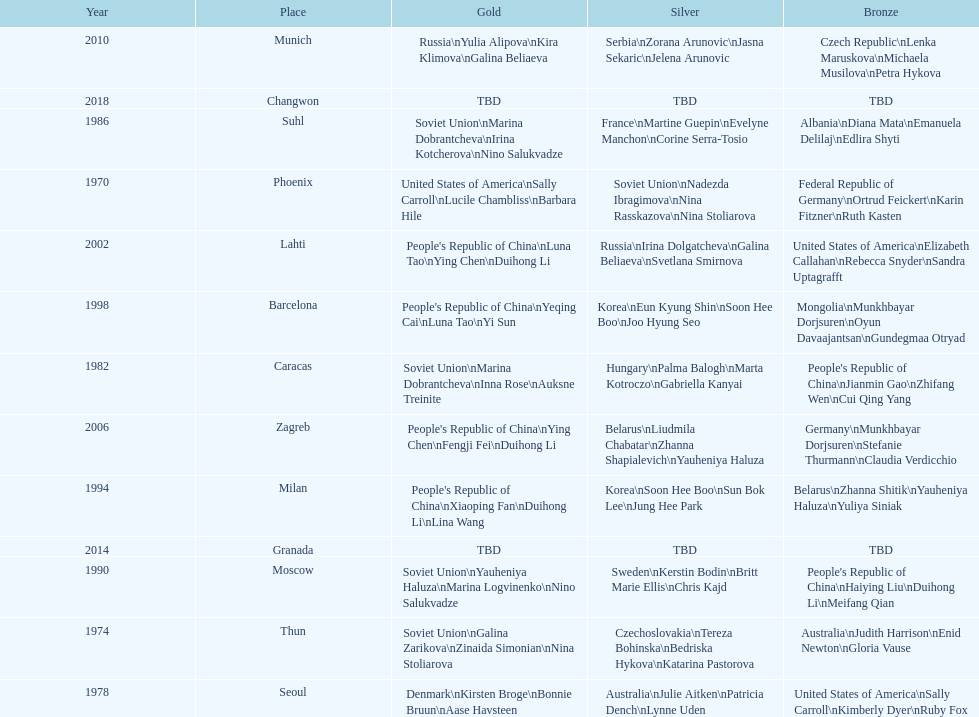Whose name is listed before bonnie bruun's in the gold column? Kirsten Broge. 